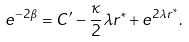<formula> <loc_0><loc_0><loc_500><loc_500>e ^ { - 2 \beta } = C ^ { \prime } - \frac { \kappa } { 2 } \lambda r ^ { * } + e ^ { 2 \lambda r ^ { * } } .</formula> 